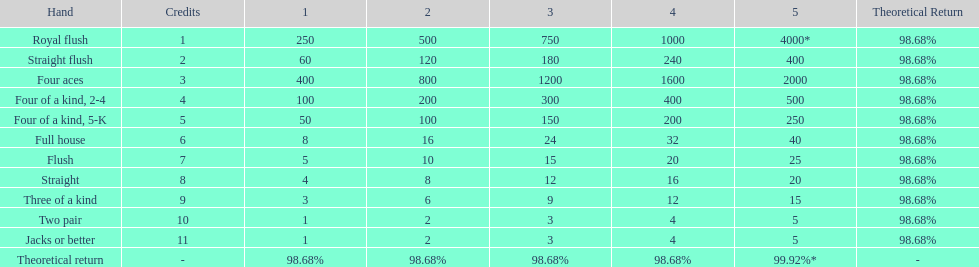What is the total amount of a 3 credit straight flush? 180. 